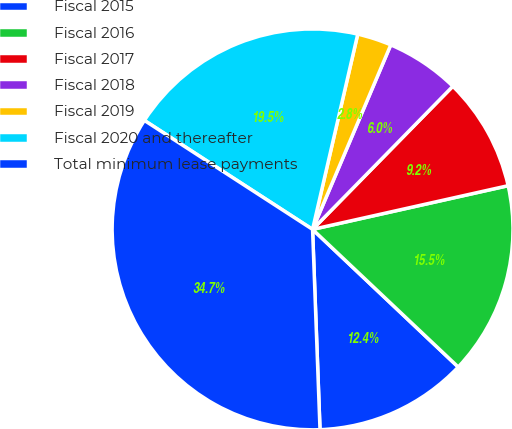Convert chart to OTSL. <chart><loc_0><loc_0><loc_500><loc_500><pie_chart><fcel>Fiscal 2015<fcel>Fiscal 2016<fcel>Fiscal 2017<fcel>Fiscal 2018<fcel>Fiscal 2019<fcel>Fiscal 2020 and thereafter<fcel>Total minimum lease payments<nl><fcel>12.36%<fcel>15.55%<fcel>9.16%<fcel>5.96%<fcel>2.76%<fcel>19.47%<fcel>34.74%<nl></chart> 